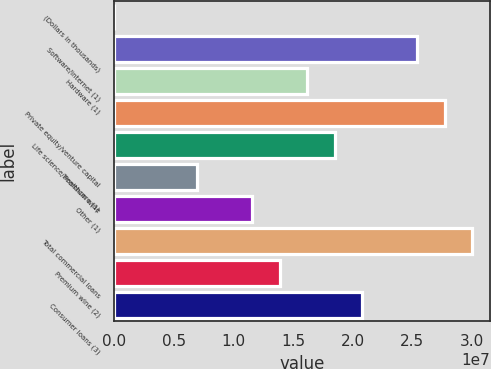Convert chart to OTSL. <chart><loc_0><loc_0><loc_500><loc_500><bar_chart><fcel>(Dollars in thousands)<fcel>Software/internet (1)<fcel>Hardware (1)<fcel>Private equity/venture capital<fcel>Life science/healthcare (1)<fcel>Premium wine<fcel>Other (1)<fcel>Total commercial loans<fcel>Premium wine (2)<fcel>Consumer loans (3)<nl><fcel>2017<fcel>2.54167e+07<fcel>1.6175e+07<fcel>2.77272e+07<fcel>1.84855e+07<fcel>6.93331e+06<fcel>1.15542e+07<fcel>3.00376e+07<fcel>1.38646e+07<fcel>2.07959e+07<nl></chart> 